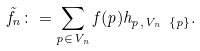Convert formula to latex. <formula><loc_0><loc_0><loc_500><loc_500>\tilde { f } _ { n } \colon = \sum _ { p \in V _ { n } } f ( p ) { h } _ { p , V _ { n } \ \{ p \} } .</formula> 